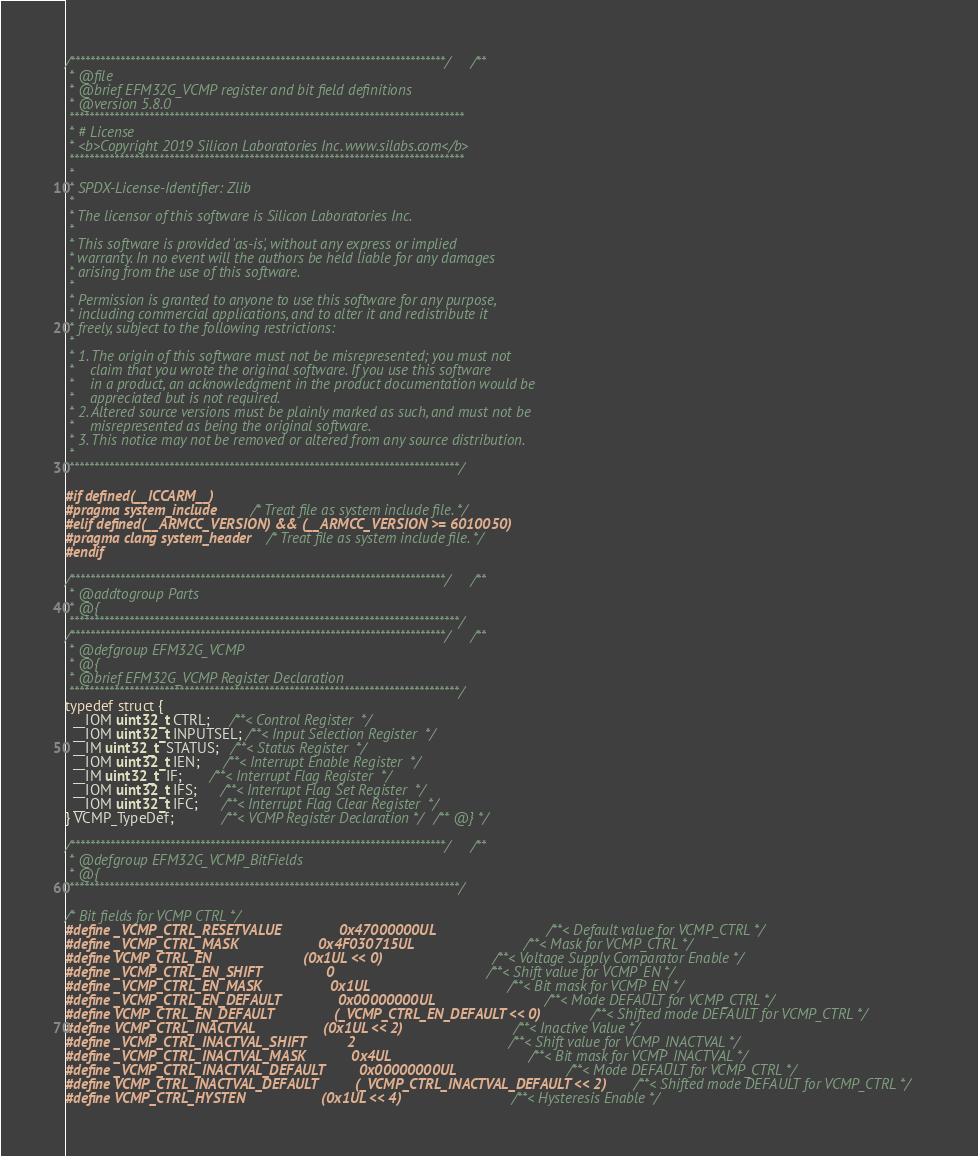<code> <loc_0><loc_0><loc_500><loc_500><_C_>/***************************************************************************//**
 * @file
 * @brief EFM32G_VCMP register and bit field definitions
 * @version 5.8.0
 *******************************************************************************
 * # License
 * <b>Copyright 2019 Silicon Laboratories Inc. www.silabs.com</b>
 *******************************************************************************
 *
 * SPDX-License-Identifier: Zlib
 *
 * The licensor of this software is Silicon Laboratories Inc.
 *
 * This software is provided 'as-is', without any express or implied
 * warranty. In no event will the authors be held liable for any damages
 * arising from the use of this software.
 *
 * Permission is granted to anyone to use this software for any purpose,
 * including commercial applications, and to alter it and redistribute it
 * freely, subject to the following restrictions:
 *
 * 1. The origin of this software must not be misrepresented; you must not
 *    claim that you wrote the original software. If you use this software
 *    in a product, an acknowledgment in the product documentation would be
 *    appreciated but is not required.
 * 2. Altered source versions must be plainly marked as such, and must not be
 *    misrepresented as being the original software.
 * 3. This notice may not be removed or altered from any source distribution.
 *
 ******************************************************************************/

#if defined(__ICCARM__)
#pragma system_include       /* Treat file as system include file. */
#elif defined(__ARMCC_VERSION) && (__ARMCC_VERSION >= 6010050)
#pragma clang system_header  /* Treat file as system include file. */
#endif

/***************************************************************************//**
 * @addtogroup Parts
 * @{
 ******************************************************************************/
/***************************************************************************//**
 * @defgroup EFM32G_VCMP
 * @{
 * @brief EFM32G_VCMP Register Declaration
 ******************************************************************************/
typedef struct {
  __IOM uint32_t CTRL;     /**< Control Register  */
  __IOM uint32_t INPUTSEL; /**< Input Selection Register  */
  __IM uint32_t  STATUS;   /**< Status Register  */
  __IOM uint32_t IEN;      /**< Interrupt Enable Register  */
  __IM uint32_t  IF;       /**< Interrupt Flag Register  */
  __IOM uint32_t IFS;      /**< Interrupt Flag Set Register  */
  __IOM uint32_t IFC;      /**< Interrupt Flag Clear Register  */
} VCMP_TypeDef;            /**< VCMP Register Declaration *//** @} */

/***************************************************************************//**
 * @defgroup EFM32G_VCMP_BitFields
 * @{
 ******************************************************************************/

/* Bit fields for VCMP CTRL */
#define _VCMP_CTRL_RESETVALUE               0x47000000UL                         /**< Default value for VCMP_CTRL */
#define _VCMP_CTRL_MASK                     0x4F030715UL                         /**< Mask for VCMP_CTRL */
#define VCMP_CTRL_EN                        (0x1UL << 0)                         /**< Voltage Supply Comparator Enable */
#define _VCMP_CTRL_EN_SHIFT                 0                                    /**< Shift value for VCMP_EN */
#define _VCMP_CTRL_EN_MASK                  0x1UL                                /**< Bit mask for VCMP_EN */
#define _VCMP_CTRL_EN_DEFAULT               0x00000000UL                         /**< Mode DEFAULT for VCMP_CTRL */
#define VCMP_CTRL_EN_DEFAULT                (_VCMP_CTRL_EN_DEFAULT << 0)         /**< Shifted mode DEFAULT for VCMP_CTRL */
#define VCMP_CTRL_INACTVAL                  (0x1UL << 2)                         /**< Inactive Value */
#define _VCMP_CTRL_INACTVAL_SHIFT           2                                    /**< Shift value for VCMP_INACTVAL */
#define _VCMP_CTRL_INACTVAL_MASK            0x4UL                                /**< Bit mask for VCMP_INACTVAL */
#define _VCMP_CTRL_INACTVAL_DEFAULT         0x00000000UL                         /**< Mode DEFAULT for VCMP_CTRL */
#define VCMP_CTRL_INACTVAL_DEFAULT          (_VCMP_CTRL_INACTVAL_DEFAULT << 2)   /**< Shifted mode DEFAULT for VCMP_CTRL */
#define VCMP_CTRL_HYSTEN                    (0x1UL << 4)                         /**< Hysteresis Enable */</code> 